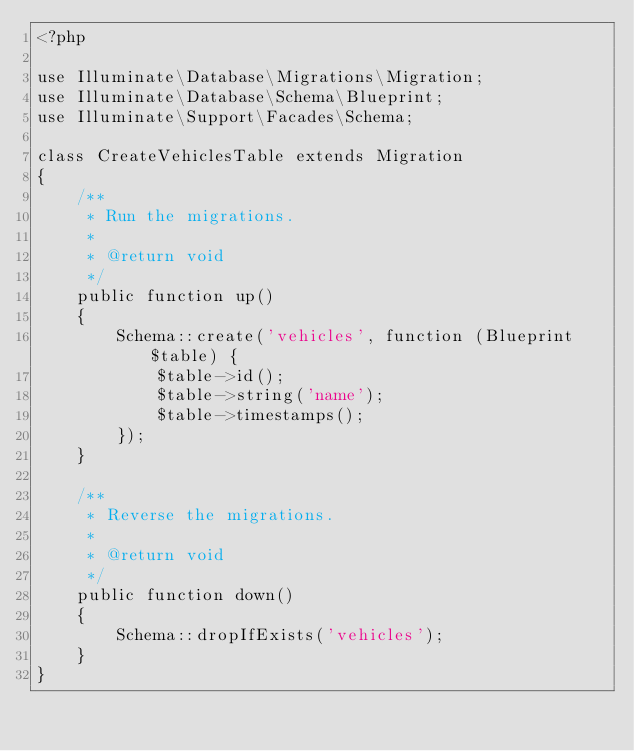Convert code to text. <code><loc_0><loc_0><loc_500><loc_500><_PHP_><?php

use Illuminate\Database\Migrations\Migration;
use Illuminate\Database\Schema\Blueprint;
use Illuminate\Support\Facades\Schema;

class CreateVehiclesTable extends Migration
{
    /**
     * Run the migrations.
     *
     * @return void
     */
    public function up()
    {
        Schema::create('vehicles', function (Blueprint $table) {
            $table->id();
            $table->string('name');
            $table->timestamps();
        });
    }

    /**
     * Reverse the migrations.
     *
     * @return void
     */
    public function down()
    {
        Schema::dropIfExists('vehicles');
    }
}
</code> 